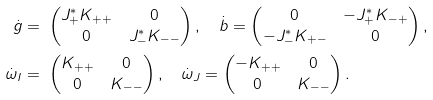Convert formula to latex. <formula><loc_0><loc_0><loc_500><loc_500>\dot { g } = & \ \begin{pmatrix} J _ { + } ^ { * } K _ { + + } & 0 \\ 0 & J _ { - } ^ { * } K _ { - - } \end{pmatrix} , \quad \dot { b } = \begin{pmatrix} 0 & - J _ { + } ^ { * } K _ { - + } \\ - J _ { - } ^ { * } K _ { + - } & 0 \end{pmatrix} , \\ \dot { \omega } _ { I } = & \ \begin{pmatrix} K _ { + + } & 0 \\ 0 & K _ { - - } \end{pmatrix} , \quad \dot { \omega } _ { J } = \begin{pmatrix} - K _ { + + } & 0 \\ 0 & K _ { - - } \end{pmatrix} .</formula> 